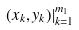Convert formula to latex. <formula><loc_0><loc_0><loc_500><loc_500>( x _ { k } , y _ { k } ) | _ { k = 1 } ^ { m _ { 1 } }</formula> 